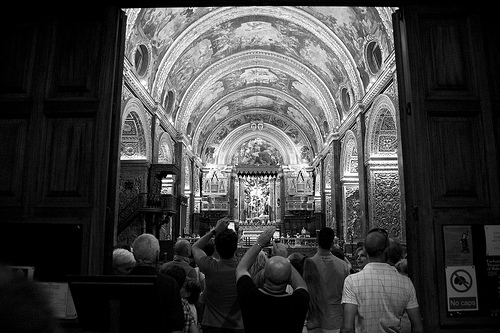Who might be the people in the image and what are they doing? The people in the image are likely visitors or tourists. They seem to be admiring the beauty of the church's interior, some possibly taking photographs to capture the intricate details. 